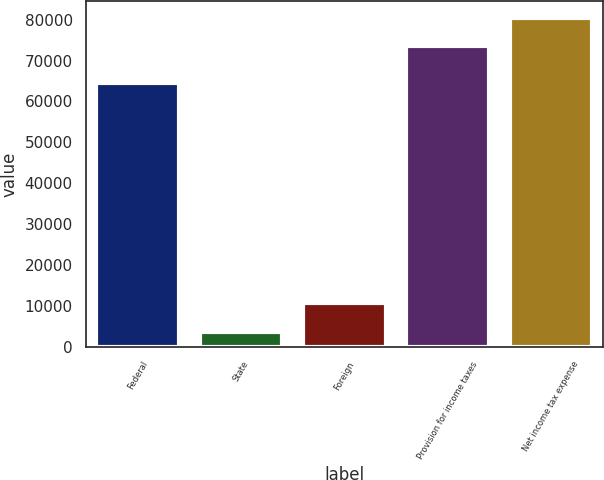<chart> <loc_0><loc_0><loc_500><loc_500><bar_chart><fcel>Federal<fcel>State<fcel>Foreign<fcel>Provision for income taxes<fcel>Net income tax expense<nl><fcel>64579<fcel>3501<fcel>10564.1<fcel>73436<fcel>80499.1<nl></chart> 